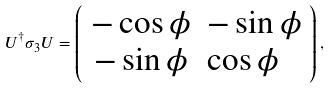Convert formula to latex. <formula><loc_0><loc_0><loc_500><loc_500>U ^ { \dag } \sigma _ { 3 } U = \left ( \begin{array} { c l c r } - \cos \phi & - \sin \phi \\ - \sin \phi & \cos \phi \end{array} \right ) ,</formula> 